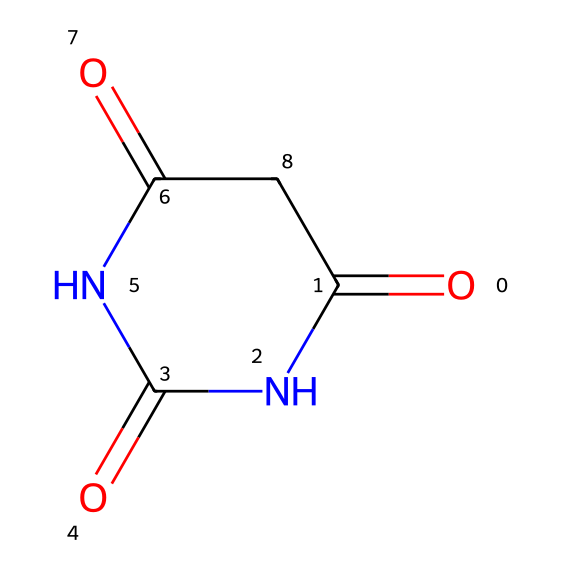What is the molecular formula of barbituric acid? To determine the molecular formula, we can count the number of each type of atom in the chemical structure. From the SMILES representation, we identify 4 carbon (C), 4 nitrogen (N), and 6 oxygen (O) atoms present, leading to the formula C4H4N4O3.
Answer: C4H4N4O3 How many nitrogen atoms are present in barbituric acid? By examining the SMILES representation, we count the nitrogen atoms enclosed in the structure. There are a total of 4 nitrogen (N) atoms in the molecular arrangement.
Answer: 4 What type of hybridization is expected for the nitrogen atoms in barbituric acid? Each nitrogen in barbituric acid is involved in creating resonance structures with adjacent carbonyl groups and can be assumed to have a hybridization of sp2 due to the presence of a double bond with oxygen.
Answer: sp2 Which functional groups are present in barbituric acid? Analyzing the structure, we identify the presence of amide groups (due to the carbonyl and nitrogen bonds) and carbonyl groups, as indicated by the -C(=O)- format. Therefore, the primary functional groups are amides and carbonyls.
Answer: amides, carbonyls What role does barbituric acid play in medicinal chemistry? Barbituric acid is a precursor to barbiturates, which are a class of drugs used as sedatives and anesthetics. Its structural characteristics enable it to interact with the central nervous system effectively.
Answer: precursor to barbiturates Identify if barbituric acid can exhibit resonance. Barbituric acid has multiple resonance structures due to the ability of electron delocalization across the nitrogen and carbonyl groups, allowing potential shifts of electrons. This resonance stabilization is important for its reactivity and interaction with biological targets.
Answer: yes What type of compound is barbituric acid classified as? Given the functional groups and structural characteristics, barbituric acid fits the definition of an imide because it contains two carbonyl groups adjacent to a nitrogen atom, typical for imides.
Answer: imide 